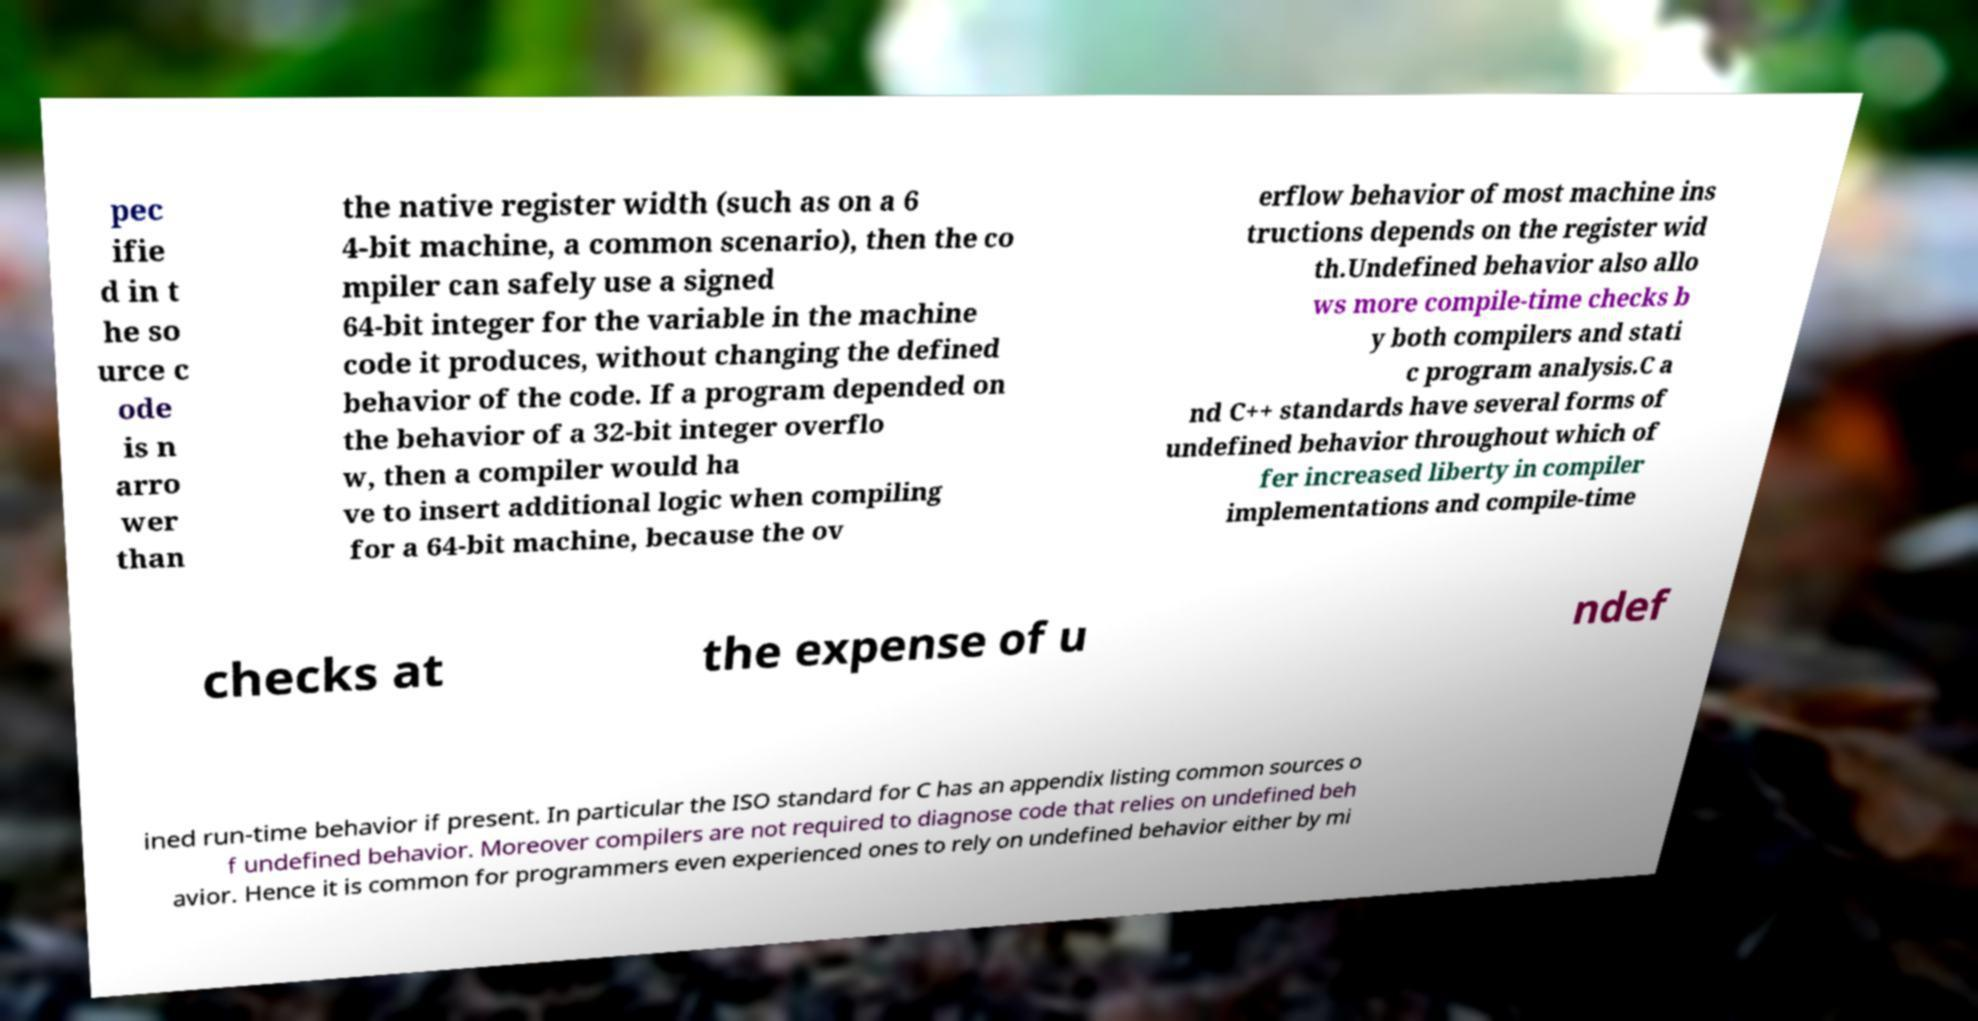There's text embedded in this image that I need extracted. Can you transcribe it verbatim? pec ifie d in t he so urce c ode is n arro wer than the native register width (such as on a 6 4-bit machine, a common scenario), then the co mpiler can safely use a signed 64-bit integer for the variable in the machine code it produces, without changing the defined behavior of the code. If a program depended on the behavior of a 32-bit integer overflo w, then a compiler would ha ve to insert additional logic when compiling for a 64-bit machine, because the ov erflow behavior of most machine ins tructions depends on the register wid th.Undefined behavior also allo ws more compile-time checks b y both compilers and stati c program analysis.C a nd C++ standards have several forms of undefined behavior throughout which of fer increased liberty in compiler implementations and compile-time checks at the expense of u ndef ined run-time behavior if present. In particular the ISO standard for C has an appendix listing common sources o f undefined behavior. Moreover compilers are not required to diagnose code that relies on undefined beh avior. Hence it is common for programmers even experienced ones to rely on undefined behavior either by mi 